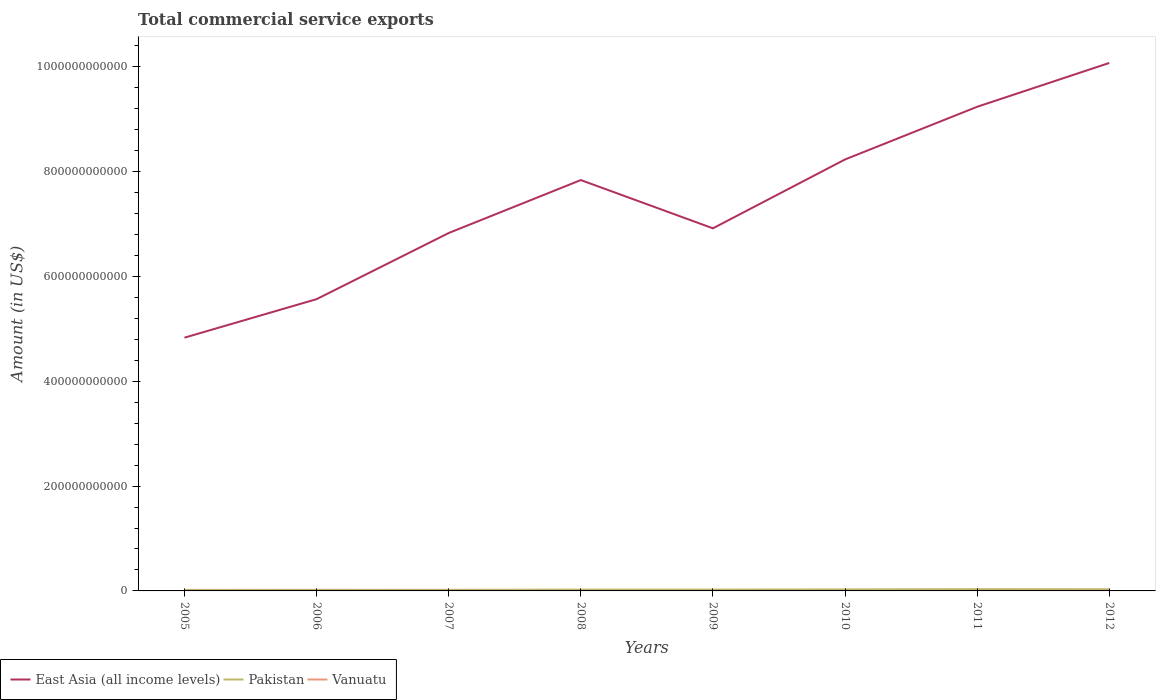How many different coloured lines are there?
Offer a terse response. 3. Across all years, what is the maximum total commercial service exports in Vanuatu?
Offer a very short reply. 1.35e+08. In which year was the total commercial service exports in East Asia (all income levels) maximum?
Provide a succinct answer. 2005. What is the total total commercial service exports in East Asia (all income levels) in the graph?
Offer a terse response. -1.84e+11. What is the difference between the highest and the second highest total commercial service exports in East Asia (all income levels)?
Your response must be concise. 5.24e+11. What is the difference between the highest and the lowest total commercial service exports in Vanuatu?
Offer a terse response. 5. Is the total commercial service exports in East Asia (all income levels) strictly greater than the total commercial service exports in Pakistan over the years?
Provide a succinct answer. No. What is the difference between two consecutive major ticks on the Y-axis?
Give a very brief answer. 2.00e+11. Where does the legend appear in the graph?
Provide a succinct answer. Bottom left. How many legend labels are there?
Make the answer very short. 3. What is the title of the graph?
Ensure brevity in your answer.  Total commercial service exports. What is the Amount (in US$) in East Asia (all income levels) in 2005?
Your answer should be compact. 4.83e+11. What is the Amount (in US$) in Pakistan in 2005?
Ensure brevity in your answer.  2.03e+09. What is the Amount (in US$) in Vanuatu in 2005?
Your answer should be compact. 1.35e+08. What is the Amount (in US$) in East Asia (all income levels) in 2006?
Your response must be concise. 5.57e+11. What is the Amount (in US$) of Pakistan in 2006?
Provide a short and direct response. 2.22e+09. What is the Amount (in US$) in Vanuatu in 2006?
Ensure brevity in your answer.  1.40e+08. What is the Amount (in US$) in East Asia (all income levels) in 2007?
Ensure brevity in your answer.  6.83e+11. What is the Amount (in US$) in Pakistan in 2007?
Keep it short and to the point. 2.18e+09. What is the Amount (in US$) in Vanuatu in 2007?
Provide a succinct answer. 1.77e+08. What is the Amount (in US$) of East Asia (all income levels) in 2008?
Give a very brief answer. 7.84e+11. What is the Amount (in US$) of Pakistan in 2008?
Offer a terse response. 2.52e+09. What is the Amount (in US$) of Vanuatu in 2008?
Your response must be concise. 2.25e+08. What is the Amount (in US$) in East Asia (all income levels) in 2009?
Your answer should be very brief. 6.92e+11. What is the Amount (in US$) in Pakistan in 2009?
Provide a short and direct response. 2.52e+09. What is the Amount (in US$) in Vanuatu in 2009?
Provide a short and direct response. 2.41e+08. What is the Amount (in US$) in East Asia (all income levels) in 2010?
Provide a succinct answer. 8.23e+11. What is the Amount (in US$) of Pakistan in 2010?
Give a very brief answer. 2.93e+09. What is the Amount (in US$) of Vanuatu in 2010?
Your answer should be compact. 2.71e+08. What is the Amount (in US$) in East Asia (all income levels) in 2011?
Offer a very short reply. 9.24e+11. What is the Amount (in US$) of Pakistan in 2011?
Provide a succinct answer. 3.37e+09. What is the Amount (in US$) of Vanuatu in 2011?
Ensure brevity in your answer.  2.81e+08. What is the Amount (in US$) in East Asia (all income levels) in 2012?
Offer a very short reply. 1.01e+12. What is the Amount (in US$) in Pakistan in 2012?
Give a very brief answer. 3.20e+09. What is the Amount (in US$) in Vanuatu in 2012?
Ensure brevity in your answer.  3.15e+08. Across all years, what is the maximum Amount (in US$) in East Asia (all income levels)?
Keep it short and to the point. 1.01e+12. Across all years, what is the maximum Amount (in US$) of Pakistan?
Make the answer very short. 3.37e+09. Across all years, what is the maximum Amount (in US$) in Vanuatu?
Keep it short and to the point. 3.15e+08. Across all years, what is the minimum Amount (in US$) of East Asia (all income levels)?
Provide a short and direct response. 4.83e+11. Across all years, what is the minimum Amount (in US$) of Pakistan?
Offer a very short reply. 2.03e+09. Across all years, what is the minimum Amount (in US$) in Vanuatu?
Ensure brevity in your answer.  1.35e+08. What is the total Amount (in US$) of East Asia (all income levels) in the graph?
Offer a terse response. 5.95e+12. What is the total Amount (in US$) in Pakistan in the graph?
Your answer should be compact. 2.10e+1. What is the total Amount (in US$) of Vanuatu in the graph?
Ensure brevity in your answer.  1.79e+09. What is the difference between the Amount (in US$) of East Asia (all income levels) in 2005 and that in 2006?
Ensure brevity in your answer.  -7.35e+1. What is the difference between the Amount (in US$) of Pakistan in 2005 and that in 2006?
Offer a terse response. -1.85e+08. What is the difference between the Amount (in US$) in Vanuatu in 2005 and that in 2006?
Offer a very short reply. -5.24e+06. What is the difference between the Amount (in US$) in East Asia (all income levels) in 2005 and that in 2007?
Your answer should be very brief. -2.00e+11. What is the difference between the Amount (in US$) in Pakistan in 2005 and that in 2007?
Provide a succinct answer. -1.48e+08. What is the difference between the Amount (in US$) of Vanuatu in 2005 and that in 2007?
Your answer should be very brief. -4.22e+07. What is the difference between the Amount (in US$) in East Asia (all income levels) in 2005 and that in 2008?
Your response must be concise. -3.01e+11. What is the difference between the Amount (in US$) of Pakistan in 2005 and that in 2008?
Your answer should be compact. -4.85e+08. What is the difference between the Amount (in US$) in Vanuatu in 2005 and that in 2008?
Your response must be concise. -9.04e+07. What is the difference between the Amount (in US$) of East Asia (all income levels) in 2005 and that in 2009?
Make the answer very short. -2.09e+11. What is the difference between the Amount (in US$) in Pakistan in 2005 and that in 2009?
Provide a succinct answer. -4.92e+08. What is the difference between the Amount (in US$) in Vanuatu in 2005 and that in 2009?
Provide a short and direct response. -1.06e+08. What is the difference between the Amount (in US$) of East Asia (all income levels) in 2005 and that in 2010?
Your answer should be very brief. -3.40e+11. What is the difference between the Amount (in US$) in Pakistan in 2005 and that in 2010?
Provide a succinct answer. -9.01e+08. What is the difference between the Amount (in US$) of Vanuatu in 2005 and that in 2010?
Make the answer very short. -1.36e+08. What is the difference between the Amount (in US$) of East Asia (all income levels) in 2005 and that in 2011?
Offer a terse response. -4.40e+11. What is the difference between the Amount (in US$) of Pakistan in 2005 and that in 2011?
Give a very brief answer. -1.34e+09. What is the difference between the Amount (in US$) of Vanuatu in 2005 and that in 2011?
Your answer should be compact. -1.47e+08. What is the difference between the Amount (in US$) in East Asia (all income levels) in 2005 and that in 2012?
Make the answer very short. -5.24e+11. What is the difference between the Amount (in US$) in Pakistan in 2005 and that in 2012?
Your answer should be compact. -1.17e+09. What is the difference between the Amount (in US$) in Vanuatu in 2005 and that in 2012?
Provide a succinct answer. -1.80e+08. What is the difference between the Amount (in US$) in East Asia (all income levels) in 2006 and that in 2007?
Provide a short and direct response. -1.26e+11. What is the difference between the Amount (in US$) in Pakistan in 2006 and that in 2007?
Make the answer very short. 3.73e+07. What is the difference between the Amount (in US$) in Vanuatu in 2006 and that in 2007?
Offer a terse response. -3.69e+07. What is the difference between the Amount (in US$) in East Asia (all income levels) in 2006 and that in 2008?
Ensure brevity in your answer.  -2.27e+11. What is the difference between the Amount (in US$) of Pakistan in 2006 and that in 2008?
Provide a succinct answer. -3.00e+08. What is the difference between the Amount (in US$) in Vanuatu in 2006 and that in 2008?
Provide a succinct answer. -8.52e+07. What is the difference between the Amount (in US$) of East Asia (all income levels) in 2006 and that in 2009?
Make the answer very short. -1.35e+11. What is the difference between the Amount (in US$) of Pakistan in 2006 and that in 2009?
Your answer should be very brief. -3.07e+08. What is the difference between the Amount (in US$) of Vanuatu in 2006 and that in 2009?
Give a very brief answer. -1.01e+08. What is the difference between the Amount (in US$) of East Asia (all income levels) in 2006 and that in 2010?
Your answer should be very brief. -2.66e+11. What is the difference between the Amount (in US$) in Pakistan in 2006 and that in 2010?
Provide a short and direct response. -7.16e+08. What is the difference between the Amount (in US$) of Vanuatu in 2006 and that in 2010?
Offer a very short reply. -1.31e+08. What is the difference between the Amount (in US$) of East Asia (all income levels) in 2006 and that in 2011?
Your answer should be compact. -3.67e+11. What is the difference between the Amount (in US$) of Pakistan in 2006 and that in 2011?
Make the answer very short. -1.16e+09. What is the difference between the Amount (in US$) in Vanuatu in 2006 and that in 2011?
Offer a terse response. -1.41e+08. What is the difference between the Amount (in US$) of East Asia (all income levels) in 2006 and that in 2012?
Provide a succinct answer. -4.51e+11. What is the difference between the Amount (in US$) of Pakistan in 2006 and that in 2012?
Provide a short and direct response. -9.89e+08. What is the difference between the Amount (in US$) in Vanuatu in 2006 and that in 2012?
Provide a short and direct response. -1.75e+08. What is the difference between the Amount (in US$) of East Asia (all income levels) in 2007 and that in 2008?
Provide a short and direct response. -1.01e+11. What is the difference between the Amount (in US$) of Pakistan in 2007 and that in 2008?
Provide a succinct answer. -3.37e+08. What is the difference between the Amount (in US$) of Vanuatu in 2007 and that in 2008?
Your answer should be compact. -4.83e+07. What is the difference between the Amount (in US$) in East Asia (all income levels) in 2007 and that in 2009?
Provide a short and direct response. -8.98e+09. What is the difference between the Amount (in US$) of Pakistan in 2007 and that in 2009?
Make the answer very short. -3.44e+08. What is the difference between the Amount (in US$) in Vanuatu in 2007 and that in 2009?
Ensure brevity in your answer.  -6.40e+07. What is the difference between the Amount (in US$) of East Asia (all income levels) in 2007 and that in 2010?
Make the answer very short. -1.40e+11. What is the difference between the Amount (in US$) in Pakistan in 2007 and that in 2010?
Provide a succinct answer. -7.53e+08. What is the difference between the Amount (in US$) in Vanuatu in 2007 and that in 2010?
Keep it short and to the point. -9.42e+07. What is the difference between the Amount (in US$) in East Asia (all income levels) in 2007 and that in 2011?
Keep it short and to the point. -2.41e+11. What is the difference between the Amount (in US$) of Pakistan in 2007 and that in 2011?
Give a very brief answer. -1.20e+09. What is the difference between the Amount (in US$) in Vanuatu in 2007 and that in 2011?
Make the answer very short. -1.04e+08. What is the difference between the Amount (in US$) in East Asia (all income levels) in 2007 and that in 2012?
Keep it short and to the point. -3.24e+11. What is the difference between the Amount (in US$) of Pakistan in 2007 and that in 2012?
Your response must be concise. -1.03e+09. What is the difference between the Amount (in US$) of Vanuatu in 2007 and that in 2012?
Your answer should be very brief. -1.38e+08. What is the difference between the Amount (in US$) of East Asia (all income levels) in 2008 and that in 2009?
Give a very brief answer. 9.21e+1. What is the difference between the Amount (in US$) in Pakistan in 2008 and that in 2009?
Provide a short and direct response. -7.00e+06. What is the difference between the Amount (in US$) of Vanuatu in 2008 and that in 2009?
Your response must be concise. -1.57e+07. What is the difference between the Amount (in US$) of East Asia (all income levels) in 2008 and that in 2010?
Offer a terse response. -3.93e+1. What is the difference between the Amount (in US$) of Pakistan in 2008 and that in 2010?
Keep it short and to the point. -4.16e+08. What is the difference between the Amount (in US$) of Vanuatu in 2008 and that in 2010?
Offer a terse response. -4.59e+07. What is the difference between the Amount (in US$) in East Asia (all income levels) in 2008 and that in 2011?
Offer a very short reply. -1.40e+11. What is the difference between the Amount (in US$) in Pakistan in 2008 and that in 2011?
Your answer should be compact. -8.58e+08. What is the difference between the Amount (in US$) of Vanuatu in 2008 and that in 2011?
Provide a succinct answer. -5.62e+07. What is the difference between the Amount (in US$) in East Asia (all income levels) in 2008 and that in 2012?
Your answer should be compact. -2.23e+11. What is the difference between the Amount (in US$) of Pakistan in 2008 and that in 2012?
Give a very brief answer. -6.89e+08. What is the difference between the Amount (in US$) in Vanuatu in 2008 and that in 2012?
Provide a short and direct response. -9.00e+07. What is the difference between the Amount (in US$) in East Asia (all income levels) in 2009 and that in 2010?
Provide a short and direct response. -1.31e+11. What is the difference between the Amount (in US$) of Pakistan in 2009 and that in 2010?
Give a very brief answer. -4.09e+08. What is the difference between the Amount (in US$) in Vanuatu in 2009 and that in 2010?
Offer a very short reply. -3.02e+07. What is the difference between the Amount (in US$) of East Asia (all income levels) in 2009 and that in 2011?
Provide a succinct answer. -2.32e+11. What is the difference between the Amount (in US$) in Pakistan in 2009 and that in 2011?
Offer a very short reply. -8.51e+08. What is the difference between the Amount (in US$) in Vanuatu in 2009 and that in 2011?
Provide a short and direct response. -4.05e+07. What is the difference between the Amount (in US$) in East Asia (all income levels) in 2009 and that in 2012?
Give a very brief answer. -3.15e+11. What is the difference between the Amount (in US$) in Pakistan in 2009 and that in 2012?
Make the answer very short. -6.82e+08. What is the difference between the Amount (in US$) of Vanuatu in 2009 and that in 2012?
Keep it short and to the point. -7.43e+07. What is the difference between the Amount (in US$) of East Asia (all income levels) in 2010 and that in 2011?
Make the answer very short. -1.01e+11. What is the difference between the Amount (in US$) of Pakistan in 2010 and that in 2011?
Your response must be concise. -4.42e+08. What is the difference between the Amount (in US$) of Vanuatu in 2010 and that in 2011?
Provide a short and direct response. -1.03e+07. What is the difference between the Amount (in US$) of East Asia (all income levels) in 2010 and that in 2012?
Provide a succinct answer. -1.84e+11. What is the difference between the Amount (in US$) of Pakistan in 2010 and that in 2012?
Your response must be concise. -2.73e+08. What is the difference between the Amount (in US$) of Vanuatu in 2010 and that in 2012?
Give a very brief answer. -4.41e+07. What is the difference between the Amount (in US$) of East Asia (all income levels) in 2011 and that in 2012?
Offer a very short reply. -8.36e+1. What is the difference between the Amount (in US$) of Pakistan in 2011 and that in 2012?
Offer a very short reply. 1.69e+08. What is the difference between the Amount (in US$) in Vanuatu in 2011 and that in 2012?
Keep it short and to the point. -3.38e+07. What is the difference between the Amount (in US$) of East Asia (all income levels) in 2005 and the Amount (in US$) of Pakistan in 2006?
Provide a short and direct response. 4.81e+11. What is the difference between the Amount (in US$) in East Asia (all income levels) in 2005 and the Amount (in US$) in Vanuatu in 2006?
Your answer should be compact. 4.83e+11. What is the difference between the Amount (in US$) in Pakistan in 2005 and the Amount (in US$) in Vanuatu in 2006?
Provide a succinct answer. 1.89e+09. What is the difference between the Amount (in US$) of East Asia (all income levels) in 2005 and the Amount (in US$) of Pakistan in 2007?
Offer a very short reply. 4.81e+11. What is the difference between the Amount (in US$) in East Asia (all income levels) in 2005 and the Amount (in US$) in Vanuatu in 2007?
Give a very brief answer. 4.83e+11. What is the difference between the Amount (in US$) of Pakistan in 2005 and the Amount (in US$) of Vanuatu in 2007?
Provide a succinct answer. 1.85e+09. What is the difference between the Amount (in US$) of East Asia (all income levels) in 2005 and the Amount (in US$) of Pakistan in 2008?
Keep it short and to the point. 4.81e+11. What is the difference between the Amount (in US$) of East Asia (all income levels) in 2005 and the Amount (in US$) of Vanuatu in 2008?
Offer a terse response. 4.83e+11. What is the difference between the Amount (in US$) in Pakistan in 2005 and the Amount (in US$) in Vanuatu in 2008?
Your response must be concise. 1.80e+09. What is the difference between the Amount (in US$) of East Asia (all income levels) in 2005 and the Amount (in US$) of Pakistan in 2009?
Offer a terse response. 4.81e+11. What is the difference between the Amount (in US$) in East Asia (all income levels) in 2005 and the Amount (in US$) in Vanuatu in 2009?
Offer a very short reply. 4.83e+11. What is the difference between the Amount (in US$) of Pakistan in 2005 and the Amount (in US$) of Vanuatu in 2009?
Provide a succinct answer. 1.79e+09. What is the difference between the Amount (in US$) in East Asia (all income levels) in 2005 and the Amount (in US$) in Pakistan in 2010?
Keep it short and to the point. 4.80e+11. What is the difference between the Amount (in US$) of East Asia (all income levels) in 2005 and the Amount (in US$) of Vanuatu in 2010?
Your response must be concise. 4.83e+11. What is the difference between the Amount (in US$) in Pakistan in 2005 and the Amount (in US$) in Vanuatu in 2010?
Provide a succinct answer. 1.76e+09. What is the difference between the Amount (in US$) in East Asia (all income levels) in 2005 and the Amount (in US$) in Pakistan in 2011?
Give a very brief answer. 4.80e+11. What is the difference between the Amount (in US$) in East Asia (all income levels) in 2005 and the Amount (in US$) in Vanuatu in 2011?
Provide a short and direct response. 4.83e+11. What is the difference between the Amount (in US$) in Pakistan in 2005 and the Amount (in US$) in Vanuatu in 2011?
Give a very brief answer. 1.75e+09. What is the difference between the Amount (in US$) of East Asia (all income levels) in 2005 and the Amount (in US$) of Pakistan in 2012?
Your answer should be very brief. 4.80e+11. What is the difference between the Amount (in US$) of East Asia (all income levels) in 2005 and the Amount (in US$) of Vanuatu in 2012?
Offer a very short reply. 4.83e+11. What is the difference between the Amount (in US$) of Pakistan in 2005 and the Amount (in US$) of Vanuatu in 2012?
Your answer should be very brief. 1.71e+09. What is the difference between the Amount (in US$) in East Asia (all income levels) in 2006 and the Amount (in US$) in Pakistan in 2007?
Provide a succinct answer. 5.54e+11. What is the difference between the Amount (in US$) of East Asia (all income levels) in 2006 and the Amount (in US$) of Vanuatu in 2007?
Your response must be concise. 5.56e+11. What is the difference between the Amount (in US$) in Pakistan in 2006 and the Amount (in US$) in Vanuatu in 2007?
Your response must be concise. 2.04e+09. What is the difference between the Amount (in US$) in East Asia (all income levels) in 2006 and the Amount (in US$) in Pakistan in 2008?
Offer a very short reply. 5.54e+11. What is the difference between the Amount (in US$) of East Asia (all income levels) in 2006 and the Amount (in US$) of Vanuatu in 2008?
Your response must be concise. 5.56e+11. What is the difference between the Amount (in US$) in Pakistan in 2006 and the Amount (in US$) in Vanuatu in 2008?
Offer a very short reply. 1.99e+09. What is the difference between the Amount (in US$) of East Asia (all income levels) in 2006 and the Amount (in US$) of Pakistan in 2009?
Offer a very short reply. 5.54e+11. What is the difference between the Amount (in US$) of East Asia (all income levels) in 2006 and the Amount (in US$) of Vanuatu in 2009?
Your response must be concise. 5.56e+11. What is the difference between the Amount (in US$) in Pakistan in 2006 and the Amount (in US$) in Vanuatu in 2009?
Make the answer very short. 1.97e+09. What is the difference between the Amount (in US$) in East Asia (all income levels) in 2006 and the Amount (in US$) in Pakistan in 2010?
Ensure brevity in your answer.  5.54e+11. What is the difference between the Amount (in US$) of East Asia (all income levels) in 2006 and the Amount (in US$) of Vanuatu in 2010?
Provide a succinct answer. 5.56e+11. What is the difference between the Amount (in US$) in Pakistan in 2006 and the Amount (in US$) in Vanuatu in 2010?
Provide a succinct answer. 1.94e+09. What is the difference between the Amount (in US$) in East Asia (all income levels) in 2006 and the Amount (in US$) in Pakistan in 2011?
Keep it short and to the point. 5.53e+11. What is the difference between the Amount (in US$) of East Asia (all income levels) in 2006 and the Amount (in US$) of Vanuatu in 2011?
Your answer should be very brief. 5.56e+11. What is the difference between the Amount (in US$) in Pakistan in 2006 and the Amount (in US$) in Vanuatu in 2011?
Offer a terse response. 1.93e+09. What is the difference between the Amount (in US$) in East Asia (all income levels) in 2006 and the Amount (in US$) in Pakistan in 2012?
Offer a very short reply. 5.53e+11. What is the difference between the Amount (in US$) in East Asia (all income levels) in 2006 and the Amount (in US$) in Vanuatu in 2012?
Your answer should be very brief. 5.56e+11. What is the difference between the Amount (in US$) of Pakistan in 2006 and the Amount (in US$) of Vanuatu in 2012?
Provide a succinct answer. 1.90e+09. What is the difference between the Amount (in US$) of East Asia (all income levels) in 2007 and the Amount (in US$) of Pakistan in 2008?
Make the answer very short. 6.80e+11. What is the difference between the Amount (in US$) of East Asia (all income levels) in 2007 and the Amount (in US$) of Vanuatu in 2008?
Offer a terse response. 6.83e+11. What is the difference between the Amount (in US$) in Pakistan in 2007 and the Amount (in US$) in Vanuatu in 2008?
Your answer should be compact. 1.95e+09. What is the difference between the Amount (in US$) of East Asia (all income levels) in 2007 and the Amount (in US$) of Pakistan in 2009?
Make the answer very short. 6.80e+11. What is the difference between the Amount (in US$) of East Asia (all income levels) in 2007 and the Amount (in US$) of Vanuatu in 2009?
Offer a very short reply. 6.83e+11. What is the difference between the Amount (in US$) of Pakistan in 2007 and the Amount (in US$) of Vanuatu in 2009?
Keep it short and to the point. 1.94e+09. What is the difference between the Amount (in US$) in East Asia (all income levels) in 2007 and the Amount (in US$) in Pakistan in 2010?
Provide a succinct answer. 6.80e+11. What is the difference between the Amount (in US$) of East Asia (all income levels) in 2007 and the Amount (in US$) of Vanuatu in 2010?
Offer a very short reply. 6.82e+11. What is the difference between the Amount (in US$) of Pakistan in 2007 and the Amount (in US$) of Vanuatu in 2010?
Your answer should be very brief. 1.91e+09. What is the difference between the Amount (in US$) in East Asia (all income levels) in 2007 and the Amount (in US$) in Pakistan in 2011?
Ensure brevity in your answer.  6.79e+11. What is the difference between the Amount (in US$) of East Asia (all income levels) in 2007 and the Amount (in US$) of Vanuatu in 2011?
Offer a terse response. 6.82e+11. What is the difference between the Amount (in US$) of Pakistan in 2007 and the Amount (in US$) of Vanuatu in 2011?
Offer a very short reply. 1.90e+09. What is the difference between the Amount (in US$) of East Asia (all income levels) in 2007 and the Amount (in US$) of Pakistan in 2012?
Your response must be concise. 6.80e+11. What is the difference between the Amount (in US$) of East Asia (all income levels) in 2007 and the Amount (in US$) of Vanuatu in 2012?
Provide a short and direct response. 6.82e+11. What is the difference between the Amount (in US$) in Pakistan in 2007 and the Amount (in US$) in Vanuatu in 2012?
Your answer should be very brief. 1.86e+09. What is the difference between the Amount (in US$) of East Asia (all income levels) in 2008 and the Amount (in US$) of Pakistan in 2009?
Make the answer very short. 7.81e+11. What is the difference between the Amount (in US$) of East Asia (all income levels) in 2008 and the Amount (in US$) of Vanuatu in 2009?
Offer a terse response. 7.84e+11. What is the difference between the Amount (in US$) of Pakistan in 2008 and the Amount (in US$) of Vanuatu in 2009?
Your response must be concise. 2.27e+09. What is the difference between the Amount (in US$) in East Asia (all income levels) in 2008 and the Amount (in US$) in Pakistan in 2010?
Your answer should be very brief. 7.81e+11. What is the difference between the Amount (in US$) of East Asia (all income levels) in 2008 and the Amount (in US$) of Vanuatu in 2010?
Ensure brevity in your answer.  7.84e+11. What is the difference between the Amount (in US$) in Pakistan in 2008 and the Amount (in US$) in Vanuatu in 2010?
Offer a very short reply. 2.24e+09. What is the difference between the Amount (in US$) in East Asia (all income levels) in 2008 and the Amount (in US$) in Pakistan in 2011?
Make the answer very short. 7.80e+11. What is the difference between the Amount (in US$) of East Asia (all income levels) in 2008 and the Amount (in US$) of Vanuatu in 2011?
Provide a succinct answer. 7.83e+11. What is the difference between the Amount (in US$) of Pakistan in 2008 and the Amount (in US$) of Vanuatu in 2011?
Give a very brief answer. 2.23e+09. What is the difference between the Amount (in US$) of East Asia (all income levels) in 2008 and the Amount (in US$) of Pakistan in 2012?
Offer a very short reply. 7.81e+11. What is the difference between the Amount (in US$) of East Asia (all income levels) in 2008 and the Amount (in US$) of Vanuatu in 2012?
Your response must be concise. 7.83e+11. What is the difference between the Amount (in US$) of Pakistan in 2008 and the Amount (in US$) of Vanuatu in 2012?
Your answer should be very brief. 2.20e+09. What is the difference between the Amount (in US$) of East Asia (all income levels) in 2009 and the Amount (in US$) of Pakistan in 2010?
Keep it short and to the point. 6.89e+11. What is the difference between the Amount (in US$) in East Asia (all income levels) in 2009 and the Amount (in US$) in Vanuatu in 2010?
Offer a very short reply. 6.91e+11. What is the difference between the Amount (in US$) in Pakistan in 2009 and the Amount (in US$) in Vanuatu in 2010?
Make the answer very short. 2.25e+09. What is the difference between the Amount (in US$) in East Asia (all income levels) in 2009 and the Amount (in US$) in Pakistan in 2011?
Offer a terse response. 6.88e+11. What is the difference between the Amount (in US$) of East Asia (all income levels) in 2009 and the Amount (in US$) of Vanuatu in 2011?
Offer a very short reply. 6.91e+11. What is the difference between the Amount (in US$) in Pakistan in 2009 and the Amount (in US$) in Vanuatu in 2011?
Your answer should be very brief. 2.24e+09. What is the difference between the Amount (in US$) in East Asia (all income levels) in 2009 and the Amount (in US$) in Pakistan in 2012?
Your answer should be very brief. 6.89e+11. What is the difference between the Amount (in US$) in East Asia (all income levels) in 2009 and the Amount (in US$) in Vanuatu in 2012?
Keep it short and to the point. 6.91e+11. What is the difference between the Amount (in US$) in Pakistan in 2009 and the Amount (in US$) in Vanuatu in 2012?
Provide a short and direct response. 2.21e+09. What is the difference between the Amount (in US$) of East Asia (all income levels) in 2010 and the Amount (in US$) of Pakistan in 2011?
Your response must be concise. 8.20e+11. What is the difference between the Amount (in US$) of East Asia (all income levels) in 2010 and the Amount (in US$) of Vanuatu in 2011?
Provide a short and direct response. 8.23e+11. What is the difference between the Amount (in US$) in Pakistan in 2010 and the Amount (in US$) in Vanuatu in 2011?
Make the answer very short. 2.65e+09. What is the difference between the Amount (in US$) of East Asia (all income levels) in 2010 and the Amount (in US$) of Pakistan in 2012?
Provide a succinct answer. 8.20e+11. What is the difference between the Amount (in US$) of East Asia (all income levels) in 2010 and the Amount (in US$) of Vanuatu in 2012?
Provide a short and direct response. 8.23e+11. What is the difference between the Amount (in US$) in Pakistan in 2010 and the Amount (in US$) in Vanuatu in 2012?
Your answer should be very brief. 2.62e+09. What is the difference between the Amount (in US$) of East Asia (all income levels) in 2011 and the Amount (in US$) of Pakistan in 2012?
Give a very brief answer. 9.20e+11. What is the difference between the Amount (in US$) in East Asia (all income levels) in 2011 and the Amount (in US$) in Vanuatu in 2012?
Give a very brief answer. 9.23e+11. What is the difference between the Amount (in US$) in Pakistan in 2011 and the Amount (in US$) in Vanuatu in 2012?
Provide a short and direct response. 3.06e+09. What is the average Amount (in US$) in East Asia (all income levels) per year?
Make the answer very short. 7.44e+11. What is the average Amount (in US$) of Pakistan per year?
Make the answer very short. 2.62e+09. What is the average Amount (in US$) of Vanuatu per year?
Give a very brief answer. 2.23e+08. In the year 2005, what is the difference between the Amount (in US$) in East Asia (all income levels) and Amount (in US$) in Pakistan?
Give a very brief answer. 4.81e+11. In the year 2005, what is the difference between the Amount (in US$) in East Asia (all income levels) and Amount (in US$) in Vanuatu?
Your answer should be very brief. 4.83e+11. In the year 2005, what is the difference between the Amount (in US$) of Pakistan and Amount (in US$) of Vanuatu?
Provide a short and direct response. 1.90e+09. In the year 2006, what is the difference between the Amount (in US$) of East Asia (all income levels) and Amount (in US$) of Pakistan?
Keep it short and to the point. 5.54e+11. In the year 2006, what is the difference between the Amount (in US$) of East Asia (all income levels) and Amount (in US$) of Vanuatu?
Provide a succinct answer. 5.56e+11. In the year 2006, what is the difference between the Amount (in US$) in Pakistan and Amount (in US$) in Vanuatu?
Ensure brevity in your answer.  2.08e+09. In the year 2007, what is the difference between the Amount (in US$) in East Asia (all income levels) and Amount (in US$) in Pakistan?
Your response must be concise. 6.81e+11. In the year 2007, what is the difference between the Amount (in US$) in East Asia (all income levels) and Amount (in US$) in Vanuatu?
Give a very brief answer. 6.83e+11. In the year 2007, what is the difference between the Amount (in US$) in Pakistan and Amount (in US$) in Vanuatu?
Offer a terse response. 2.00e+09. In the year 2008, what is the difference between the Amount (in US$) of East Asia (all income levels) and Amount (in US$) of Pakistan?
Provide a short and direct response. 7.81e+11. In the year 2008, what is the difference between the Amount (in US$) of East Asia (all income levels) and Amount (in US$) of Vanuatu?
Offer a terse response. 7.84e+11. In the year 2008, what is the difference between the Amount (in US$) in Pakistan and Amount (in US$) in Vanuatu?
Your response must be concise. 2.29e+09. In the year 2009, what is the difference between the Amount (in US$) in East Asia (all income levels) and Amount (in US$) in Pakistan?
Your response must be concise. 6.89e+11. In the year 2009, what is the difference between the Amount (in US$) in East Asia (all income levels) and Amount (in US$) in Vanuatu?
Provide a short and direct response. 6.91e+11. In the year 2009, what is the difference between the Amount (in US$) of Pakistan and Amount (in US$) of Vanuatu?
Keep it short and to the point. 2.28e+09. In the year 2010, what is the difference between the Amount (in US$) of East Asia (all income levels) and Amount (in US$) of Pakistan?
Keep it short and to the point. 8.20e+11. In the year 2010, what is the difference between the Amount (in US$) of East Asia (all income levels) and Amount (in US$) of Vanuatu?
Give a very brief answer. 8.23e+11. In the year 2010, what is the difference between the Amount (in US$) of Pakistan and Amount (in US$) of Vanuatu?
Keep it short and to the point. 2.66e+09. In the year 2011, what is the difference between the Amount (in US$) in East Asia (all income levels) and Amount (in US$) in Pakistan?
Provide a succinct answer. 9.20e+11. In the year 2011, what is the difference between the Amount (in US$) in East Asia (all income levels) and Amount (in US$) in Vanuatu?
Ensure brevity in your answer.  9.23e+11. In the year 2011, what is the difference between the Amount (in US$) of Pakistan and Amount (in US$) of Vanuatu?
Offer a terse response. 3.09e+09. In the year 2012, what is the difference between the Amount (in US$) in East Asia (all income levels) and Amount (in US$) in Pakistan?
Offer a very short reply. 1.00e+12. In the year 2012, what is the difference between the Amount (in US$) in East Asia (all income levels) and Amount (in US$) in Vanuatu?
Provide a short and direct response. 1.01e+12. In the year 2012, what is the difference between the Amount (in US$) of Pakistan and Amount (in US$) of Vanuatu?
Offer a very short reply. 2.89e+09. What is the ratio of the Amount (in US$) in East Asia (all income levels) in 2005 to that in 2006?
Your answer should be compact. 0.87. What is the ratio of the Amount (in US$) in Pakistan in 2005 to that in 2006?
Offer a very short reply. 0.92. What is the ratio of the Amount (in US$) of Vanuatu in 2005 to that in 2006?
Keep it short and to the point. 0.96. What is the ratio of the Amount (in US$) in East Asia (all income levels) in 2005 to that in 2007?
Your response must be concise. 0.71. What is the ratio of the Amount (in US$) of Pakistan in 2005 to that in 2007?
Your answer should be compact. 0.93. What is the ratio of the Amount (in US$) in Vanuatu in 2005 to that in 2007?
Your response must be concise. 0.76. What is the ratio of the Amount (in US$) in East Asia (all income levels) in 2005 to that in 2008?
Offer a very short reply. 0.62. What is the ratio of the Amount (in US$) in Pakistan in 2005 to that in 2008?
Keep it short and to the point. 0.81. What is the ratio of the Amount (in US$) in Vanuatu in 2005 to that in 2008?
Your response must be concise. 0.6. What is the ratio of the Amount (in US$) of East Asia (all income levels) in 2005 to that in 2009?
Give a very brief answer. 0.7. What is the ratio of the Amount (in US$) in Pakistan in 2005 to that in 2009?
Provide a succinct answer. 0.8. What is the ratio of the Amount (in US$) of Vanuatu in 2005 to that in 2009?
Give a very brief answer. 0.56. What is the ratio of the Amount (in US$) of East Asia (all income levels) in 2005 to that in 2010?
Make the answer very short. 0.59. What is the ratio of the Amount (in US$) in Pakistan in 2005 to that in 2010?
Keep it short and to the point. 0.69. What is the ratio of the Amount (in US$) of Vanuatu in 2005 to that in 2010?
Your response must be concise. 0.5. What is the ratio of the Amount (in US$) of East Asia (all income levels) in 2005 to that in 2011?
Keep it short and to the point. 0.52. What is the ratio of the Amount (in US$) of Pakistan in 2005 to that in 2011?
Your response must be concise. 0.6. What is the ratio of the Amount (in US$) of Vanuatu in 2005 to that in 2011?
Provide a succinct answer. 0.48. What is the ratio of the Amount (in US$) in East Asia (all income levels) in 2005 to that in 2012?
Provide a short and direct response. 0.48. What is the ratio of the Amount (in US$) of Pakistan in 2005 to that in 2012?
Your answer should be very brief. 0.63. What is the ratio of the Amount (in US$) of Vanuatu in 2005 to that in 2012?
Offer a very short reply. 0.43. What is the ratio of the Amount (in US$) in East Asia (all income levels) in 2006 to that in 2007?
Offer a terse response. 0.82. What is the ratio of the Amount (in US$) in Pakistan in 2006 to that in 2007?
Your answer should be very brief. 1.02. What is the ratio of the Amount (in US$) in Vanuatu in 2006 to that in 2007?
Your response must be concise. 0.79. What is the ratio of the Amount (in US$) in East Asia (all income levels) in 2006 to that in 2008?
Keep it short and to the point. 0.71. What is the ratio of the Amount (in US$) of Pakistan in 2006 to that in 2008?
Provide a succinct answer. 0.88. What is the ratio of the Amount (in US$) of Vanuatu in 2006 to that in 2008?
Offer a very short reply. 0.62. What is the ratio of the Amount (in US$) in East Asia (all income levels) in 2006 to that in 2009?
Your answer should be compact. 0.8. What is the ratio of the Amount (in US$) in Pakistan in 2006 to that in 2009?
Provide a short and direct response. 0.88. What is the ratio of the Amount (in US$) in Vanuatu in 2006 to that in 2009?
Your answer should be compact. 0.58. What is the ratio of the Amount (in US$) of East Asia (all income levels) in 2006 to that in 2010?
Provide a short and direct response. 0.68. What is the ratio of the Amount (in US$) of Pakistan in 2006 to that in 2010?
Offer a terse response. 0.76. What is the ratio of the Amount (in US$) of Vanuatu in 2006 to that in 2010?
Keep it short and to the point. 0.52. What is the ratio of the Amount (in US$) of East Asia (all income levels) in 2006 to that in 2011?
Offer a terse response. 0.6. What is the ratio of the Amount (in US$) in Pakistan in 2006 to that in 2011?
Provide a short and direct response. 0.66. What is the ratio of the Amount (in US$) of Vanuatu in 2006 to that in 2011?
Your answer should be very brief. 0.5. What is the ratio of the Amount (in US$) of East Asia (all income levels) in 2006 to that in 2012?
Offer a very short reply. 0.55. What is the ratio of the Amount (in US$) of Pakistan in 2006 to that in 2012?
Provide a short and direct response. 0.69. What is the ratio of the Amount (in US$) of Vanuatu in 2006 to that in 2012?
Ensure brevity in your answer.  0.44. What is the ratio of the Amount (in US$) of East Asia (all income levels) in 2007 to that in 2008?
Provide a short and direct response. 0.87. What is the ratio of the Amount (in US$) of Pakistan in 2007 to that in 2008?
Your answer should be compact. 0.87. What is the ratio of the Amount (in US$) of Vanuatu in 2007 to that in 2008?
Give a very brief answer. 0.79. What is the ratio of the Amount (in US$) in East Asia (all income levels) in 2007 to that in 2009?
Make the answer very short. 0.99. What is the ratio of the Amount (in US$) of Pakistan in 2007 to that in 2009?
Make the answer very short. 0.86. What is the ratio of the Amount (in US$) in Vanuatu in 2007 to that in 2009?
Give a very brief answer. 0.73. What is the ratio of the Amount (in US$) of East Asia (all income levels) in 2007 to that in 2010?
Make the answer very short. 0.83. What is the ratio of the Amount (in US$) of Pakistan in 2007 to that in 2010?
Give a very brief answer. 0.74. What is the ratio of the Amount (in US$) in Vanuatu in 2007 to that in 2010?
Keep it short and to the point. 0.65. What is the ratio of the Amount (in US$) of East Asia (all income levels) in 2007 to that in 2011?
Offer a terse response. 0.74. What is the ratio of the Amount (in US$) in Pakistan in 2007 to that in 2011?
Offer a terse response. 0.65. What is the ratio of the Amount (in US$) of Vanuatu in 2007 to that in 2011?
Provide a succinct answer. 0.63. What is the ratio of the Amount (in US$) in East Asia (all income levels) in 2007 to that in 2012?
Your response must be concise. 0.68. What is the ratio of the Amount (in US$) of Pakistan in 2007 to that in 2012?
Your response must be concise. 0.68. What is the ratio of the Amount (in US$) of Vanuatu in 2007 to that in 2012?
Ensure brevity in your answer.  0.56. What is the ratio of the Amount (in US$) of East Asia (all income levels) in 2008 to that in 2009?
Give a very brief answer. 1.13. What is the ratio of the Amount (in US$) of Pakistan in 2008 to that in 2009?
Make the answer very short. 1. What is the ratio of the Amount (in US$) in Vanuatu in 2008 to that in 2009?
Offer a very short reply. 0.93. What is the ratio of the Amount (in US$) in East Asia (all income levels) in 2008 to that in 2010?
Your answer should be compact. 0.95. What is the ratio of the Amount (in US$) in Pakistan in 2008 to that in 2010?
Provide a short and direct response. 0.86. What is the ratio of the Amount (in US$) of Vanuatu in 2008 to that in 2010?
Your answer should be very brief. 0.83. What is the ratio of the Amount (in US$) of East Asia (all income levels) in 2008 to that in 2011?
Provide a short and direct response. 0.85. What is the ratio of the Amount (in US$) of Pakistan in 2008 to that in 2011?
Your answer should be compact. 0.75. What is the ratio of the Amount (in US$) of Vanuatu in 2008 to that in 2011?
Your answer should be compact. 0.8. What is the ratio of the Amount (in US$) in East Asia (all income levels) in 2008 to that in 2012?
Provide a short and direct response. 0.78. What is the ratio of the Amount (in US$) in Pakistan in 2008 to that in 2012?
Provide a short and direct response. 0.79. What is the ratio of the Amount (in US$) of Vanuatu in 2008 to that in 2012?
Provide a short and direct response. 0.71. What is the ratio of the Amount (in US$) in East Asia (all income levels) in 2009 to that in 2010?
Your answer should be compact. 0.84. What is the ratio of the Amount (in US$) of Pakistan in 2009 to that in 2010?
Make the answer very short. 0.86. What is the ratio of the Amount (in US$) of Vanuatu in 2009 to that in 2010?
Your answer should be very brief. 0.89. What is the ratio of the Amount (in US$) of East Asia (all income levels) in 2009 to that in 2011?
Your response must be concise. 0.75. What is the ratio of the Amount (in US$) in Pakistan in 2009 to that in 2011?
Your response must be concise. 0.75. What is the ratio of the Amount (in US$) in Vanuatu in 2009 to that in 2011?
Your answer should be very brief. 0.86. What is the ratio of the Amount (in US$) of East Asia (all income levels) in 2009 to that in 2012?
Offer a terse response. 0.69. What is the ratio of the Amount (in US$) in Pakistan in 2009 to that in 2012?
Provide a short and direct response. 0.79. What is the ratio of the Amount (in US$) of Vanuatu in 2009 to that in 2012?
Keep it short and to the point. 0.76. What is the ratio of the Amount (in US$) in East Asia (all income levels) in 2010 to that in 2011?
Ensure brevity in your answer.  0.89. What is the ratio of the Amount (in US$) in Pakistan in 2010 to that in 2011?
Offer a terse response. 0.87. What is the ratio of the Amount (in US$) in Vanuatu in 2010 to that in 2011?
Your response must be concise. 0.96. What is the ratio of the Amount (in US$) in East Asia (all income levels) in 2010 to that in 2012?
Provide a succinct answer. 0.82. What is the ratio of the Amount (in US$) of Pakistan in 2010 to that in 2012?
Keep it short and to the point. 0.91. What is the ratio of the Amount (in US$) of Vanuatu in 2010 to that in 2012?
Provide a short and direct response. 0.86. What is the ratio of the Amount (in US$) in East Asia (all income levels) in 2011 to that in 2012?
Provide a short and direct response. 0.92. What is the ratio of the Amount (in US$) of Pakistan in 2011 to that in 2012?
Your answer should be very brief. 1.05. What is the ratio of the Amount (in US$) of Vanuatu in 2011 to that in 2012?
Your answer should be very brief. 0.89. What is the difference between the highest and the second highest Amount (in US$) of East Asia (all income levels)?
Your answer should be compact. 8.36e+1. What is the difference between the highest and the second highest Amount (in US$) of Pakistan?
Offer a terse response. 1.69e+08. What is the difference between the highest and the second highest Amount (in US$) in Vanuatu?
Ensure brevity in your answer.  3.38e+07. What is the difference between the highest and the lowest Amount (in US$) of East Asia (all income levels)?
Keep it short and to the point. 5.24e+11. What is the difference between the highest and the lowest Amount (in US$) in Pakistan?
Provide a short and direct response. 1.34e+09. What is the difference between the highest and the lowest Amount (in US$) of Vanuatu?
Provide a succinct answer. 1.80e+08. 